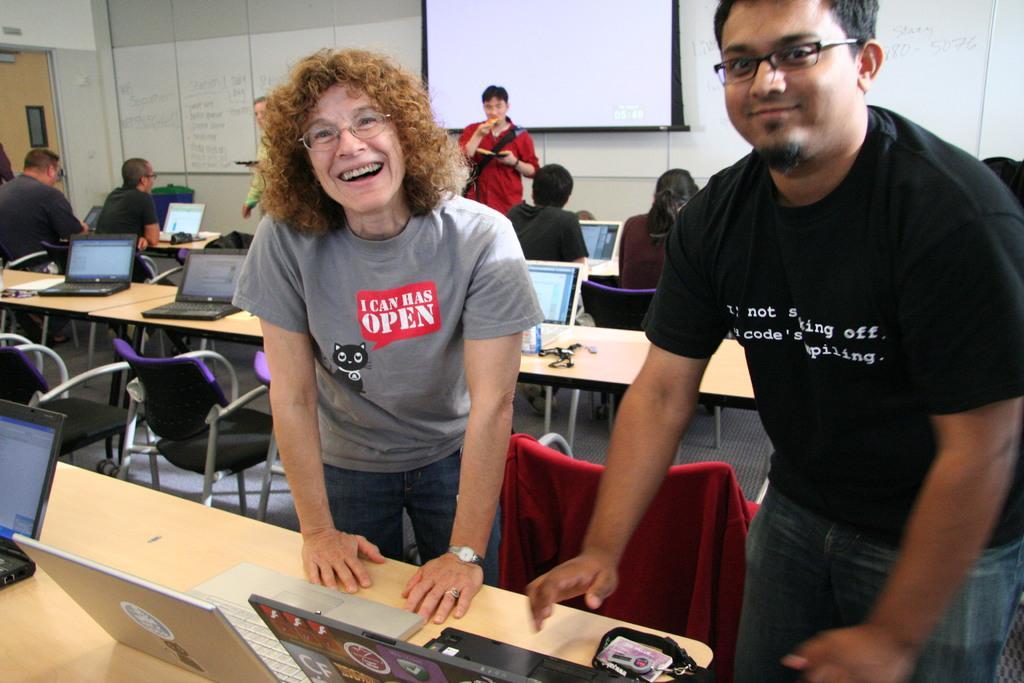How would you summarize this image in a sentence or two? A picture of a room. This 3 persons are standing. In-front of this 2 persons there is a table, on a table there are laptops. This persons are sitting, in-front of them there is a table, on a table there are laptops. Screen is attached to the wall. This is door. Far there is a bin on floor. 